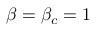Convert formula to latex. <formula><loc_0><loc_0><loc_500><loc_500>\beta = \beta _ { c } = 1</formula> 